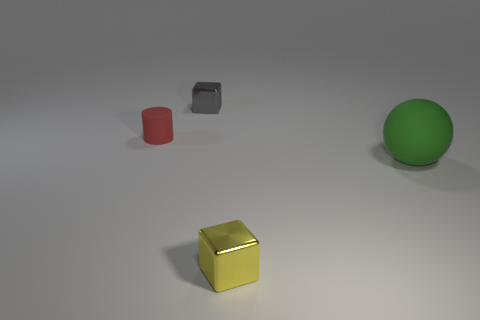Is there a green sphere of the same size as the yellow object?
Your response must be concise. No. There is a tiny metal object on the left side of the shiny cube that is to the right of the tiny gray block; what is its color?
Provide a succinct answer. Gray. What number of yellow metallic objects are there?
Your answer should be compact. 1. Is the number of tiny cubes left of the yellow shiny cube less than the number of small red matte things behind the small matte cylinder?
Provide a short and direct response. No. The small cylinder has what color?
Ensure brevity in your answer.  Red. How many large things are the same color as the matte sphere?
Offer a very short reply. 0. There is a small red rubber object; are there any matte balls left of it?
Your answer should be compact. No. Are there the same number of large green rubber balls that are on the left side of the gray cube and small gray things left of the green sphere?
Offer a very short reply. No. Is the size of the rubber object to the left of the yellow block the same as the rubber object that is to the right of the red rubber cylinder?
Give a very brief answer. No. The small object that is in front of the matte object to the right of the metallic object in front of the green sphere is what shape?
Your answer should be compact. Cube. 